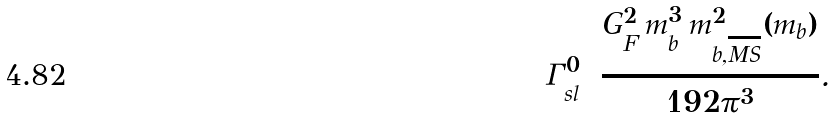<formula> <loc_0><loc_0><loc_500><loc_500>\Gamma _ { s l } ^ { 0 } = \frac { G _ { F } ^ { 2 } \, m _ { b } ^ { 3 } \, m _ { b , \overline { M S } } ^ { 2 } ( m _ { b } ) } { 1 9 2 \pi ^ { 3 } } .</formula> 